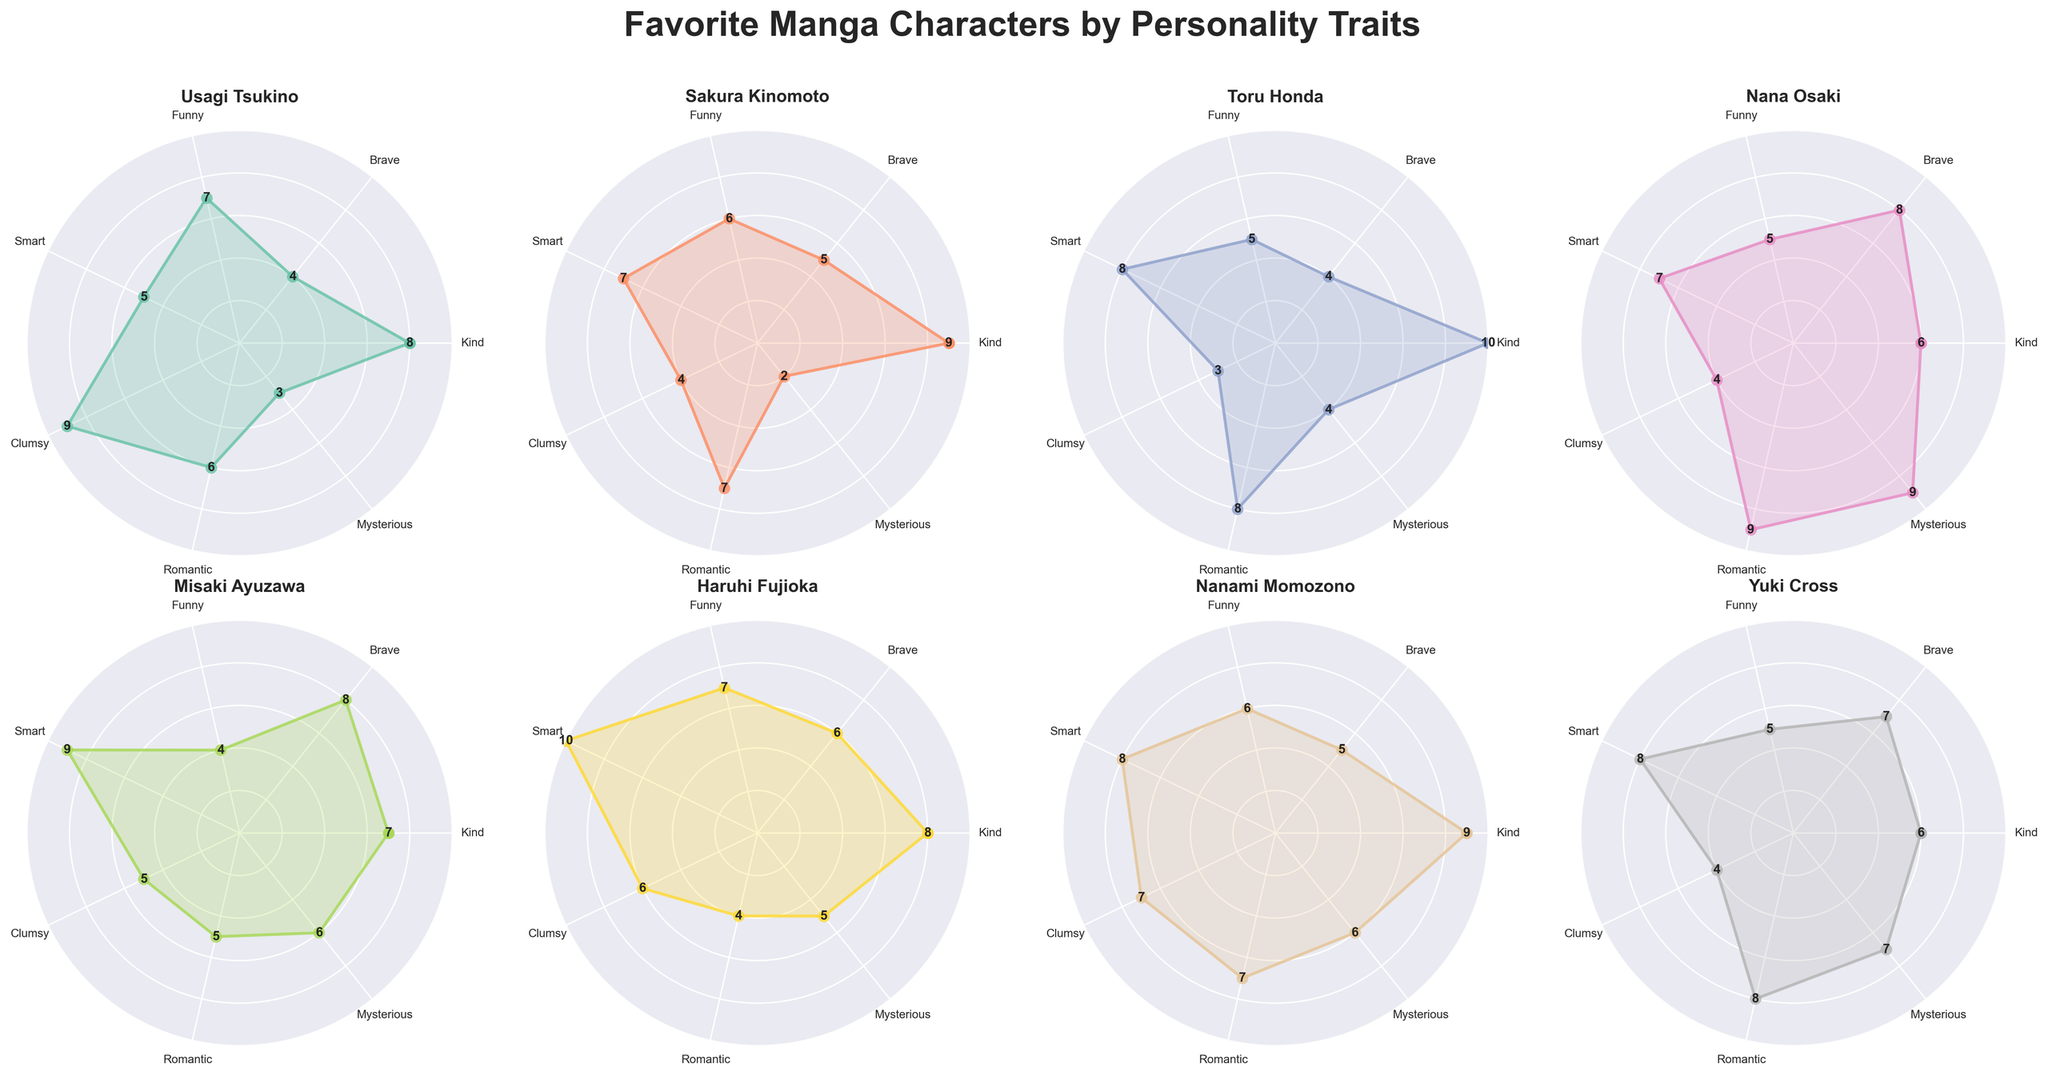Which character is the kindest? The plot indicates that Toru Honda has the highest "Kind" trait score. A quick look at her subplot shows her value is 10 in "Kind".
Answer: Toru Honda Which character is both the smartest and the clumsiest? By looking at the individual subplots, Misaki Ayuzawa stands out with the highest values in both "Smart" (9) and "Clumsy" (9).
Answer: Misaki Ayuzawa Who has the highest score in "Romantic"? The subplot values indicate that Nana Osaki has the highest score in "Romantic" with a value of 9.
Answer: Nana Osaki Compare Usagi Tsukino and Sakura Kinomoto in "Funny"; who scores higher? Usagi Tsukino has a "Funny" trait score of 7, while Sakura Kinomoto has a score of 6.
Answer: Usagi Tsukino Which character is the most mysterious according to the plot? The subplot shows Nana Osaki with the highest "Mysterious" trait score, which is 9.
Answer: Nana Osaki Which two characters have identical values in "Brave"? Both Nana Osaki and Misaki Ayuzawa have a "Brave" score of 8 according to their subplots.
Answer: Nana Osaki and Misaki Ayuzawa Compare the average values for "Kind" and "Smart" traits. Which one is higher for Yuki Cross? For Yuki Cross, the values are 6 for "Kind" and 8 for "Smart". Thus, her average values for each trait are the same, but "Smart" is clearly indicated.
Answer: Smart Which character has the lowest overall sum of trait values? By summing up the trait values for each character, Usagi Tsukino has the lowest sum:
8+4+7+5+9+6+3 = 42; the others have higher sums.
Answer: Usagi Tsukino Is there any character whose bravery and kindness scores are equal? The plots reveal that Haruhi Fujioka has equal scores for "Brave" and "Kind", both being 8.
Answer: Haruhi Fujioka 